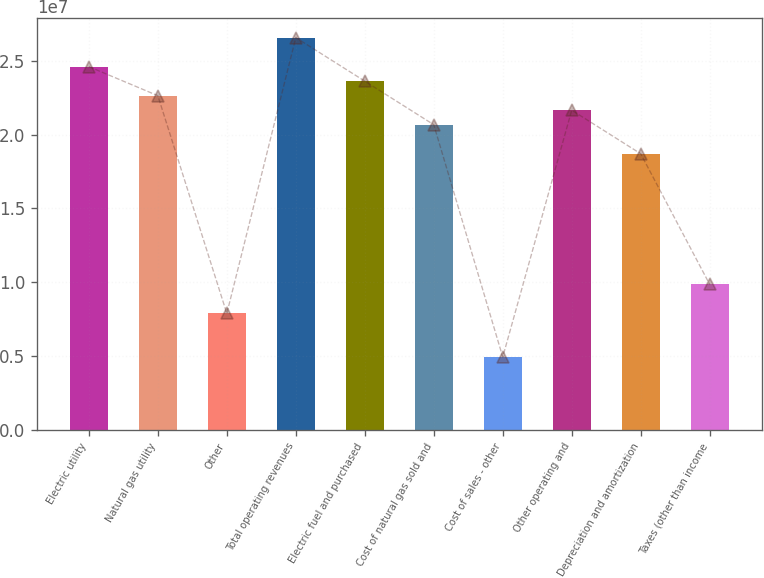Convert chart. <chart><loc_0><loc_0><loc_500><loc_500><bar_chart><fcel>Electric utility<fcel>Natural gas utility<fcel>Other<fcel>Total operating revenues<fcel>Electric fuel and purchased<fcel>Cost of natural gas sold and<fcel>Cost of sales - other<fcel>Other operating and<fcel>Depreciation and amortization<fcel>Taxes (other than income<nl><fcel>2.46008e+07<fcel>2.26327e+07<fcel>7.87224e+06<fcel>2.65688e+07<fcel>2.36167e+07<fcel>2.06646e+07<fcel>4.92015e+06<fcel>2.16487e+07<fcel>1.86966e+07<fcel>9.8403e+06<nl></chart> 